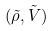<formula> <loc_0><loc_0><loc_500><loc_500>( \tilde { \rho } , \tilde { V } )</formula> 